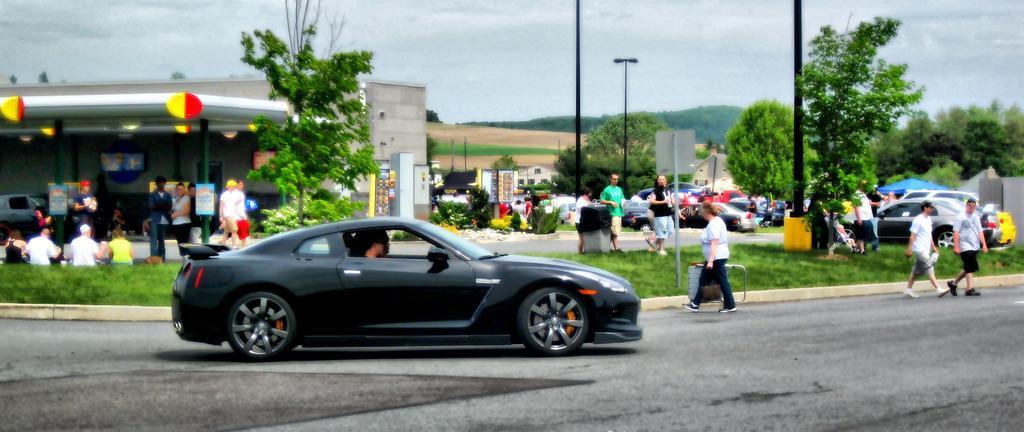Could you give a brief overview of what you see in this image? In this image in the front there is a car which is black in colour with the persons inside it. In the center there are persons walking, standing and sitting and there is grass and there are trees and there is a pole and there is a bin. In the background there are cars, trees, and persons and there are buildings and the sky is cloudy. 